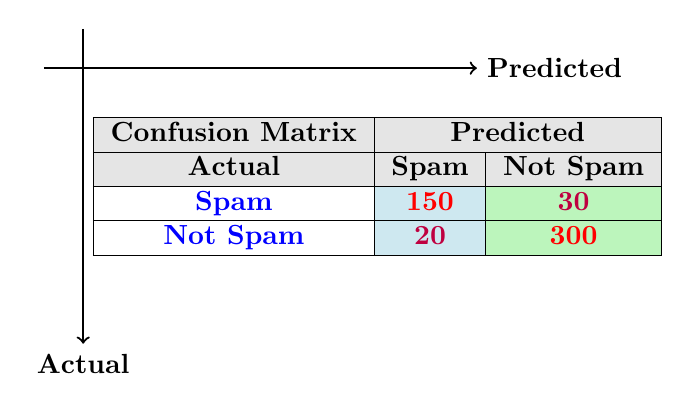What is the count of actual Spam cases that were correctly predicted as Spam? The table shows that the count for actual Spam cases predicted correctly as Spam is 150 under the "Spam" row and "Spam" column.
Answer: 150 What is the total number of Spam predictions made? To find the total Spam predictions, we sum the values from the Spam column: 150 (true positives) + 20 (false negatives) = 170.
Answer: 170 Did the model correctly identify more Not Spam cases than Spam cases? The count for Not Spam correctly identified (300) is greater than the count for Spam correctly identified (150). Hence, the model did identify more Not Spam cases.
Answer: Yes What is the count of cases that were predicted as Not Spam but were actually Spam? The table shows that 30 cases were predicted as Not Spam while they were actually Spam, represented by false negatives.
Answer: 30 What is the difference in counts between actual Spam cases and actual Not Spam cases that were predicted correctly? Subtract the count of actual Spam predicted correctly (150) from the count of actual Not Spam predicted correctly (300). The difference is 300 - 150 = 150.
Answer: 150 How many total predictions were made for Not Spam? To find the total predictions made for Not Spam, we sum the values from the Not Spam column: 30 (false positives) + 300 (true negatives) = 330.
Answer: 330 What fraction of actual Spam cases were misclassified as Not Spam? The count of actual Spam misclassified is 30, and the total actual Spam cases are 150 + 30 = 180. The fraction is 30/180, which simplifies to 1/6.
Answer: 1/6 Is the number of false positives greater than the number of false negatives? False positives (20) are less than false negatives (30), indicating that the number of false positives is not greater.
Answer: No What is the percentage of true negatives out of all predictions? The total number of predictions is 150 + 30 + 20 + 300 = 500. The number of true negatives is 300. Therefore, the percentage is (300/500) * 100 = 60%.
Answer: 60% 